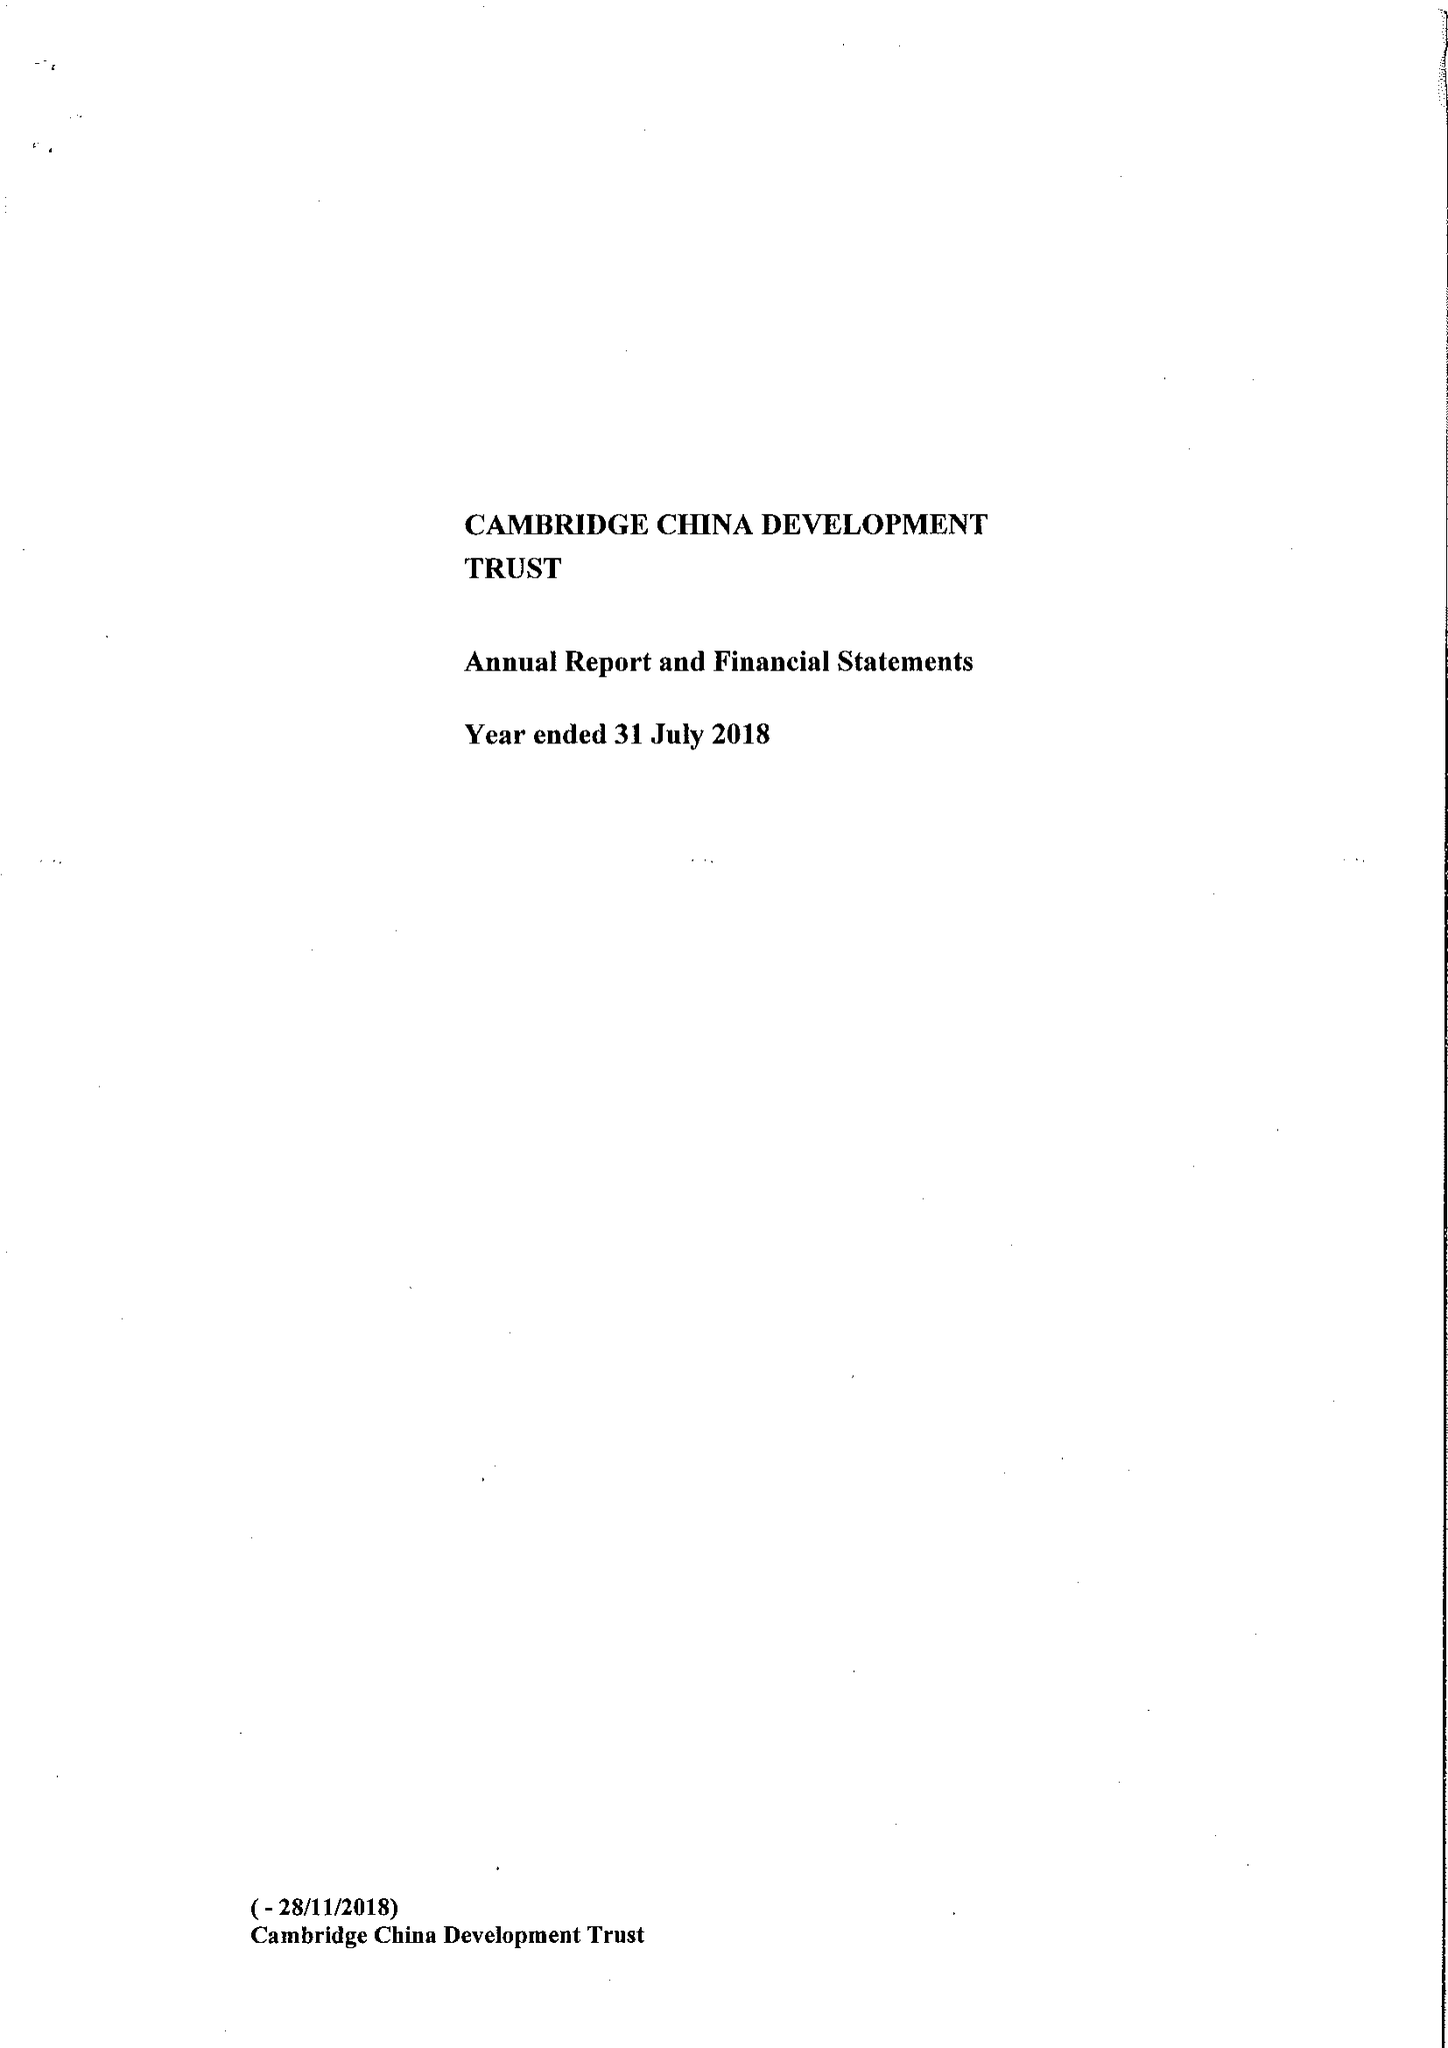What is the value for the charity_number?
Answer the question using a single word or phrase. 1111605 